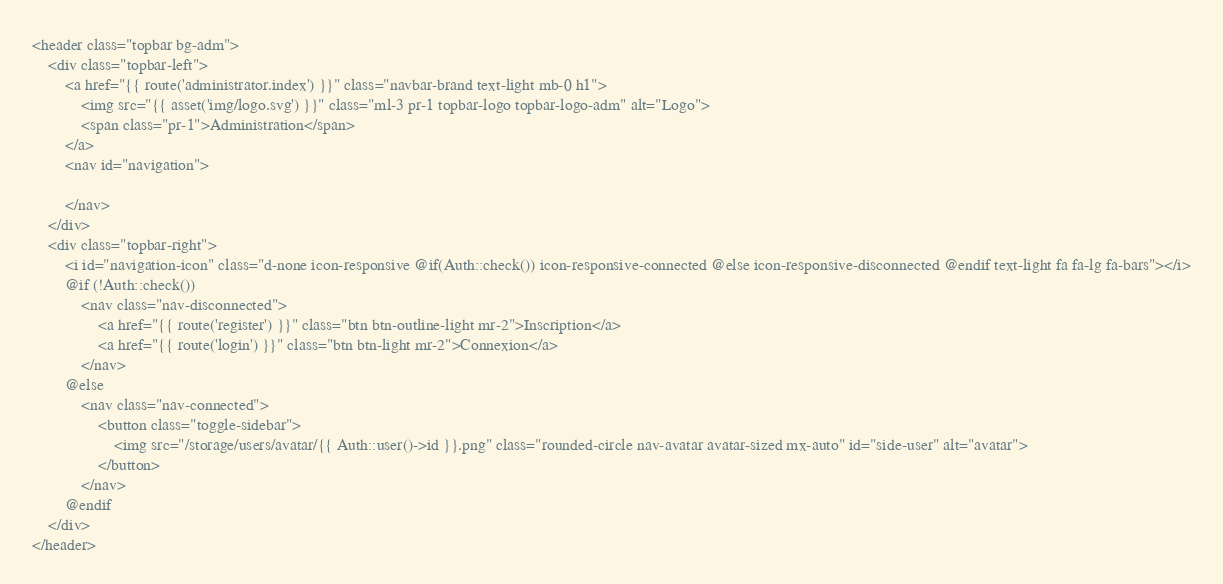<code> <loc_0><loc_0><loc_500><loc_500><_PHP_><header class="topbar bg-adm"> 
    <div class="topbar-left">      
        <a href="{{ route('administrator.index') }}" class="navbar-brand text-light mb-0 h1">
            <img src="{{ asset('img/logo.svg') }}" class="ml-3 pr-1 topbar-logo topbar-logo-adm" alt="Logo">
            <span class="pr-1">Administration</span>
        </a>
        <nav id="navigation">

        </nav>
    </div>
    <div class="topbar-right">
        <i id="navigation-icon" class="d-none icon-responsive @if(Auth::check()) icon-responsive-connected @else icon-responsive-disconnected @endif text-light fa fa-lg fa-bars"></i>
        @if (!Auth::check())
            <nav class="nav-disconnected">
                <a href="{{ route('register') }}" class="btn btn-outline-light mr-2">Inscription</a>
                <a href="{{ route('login') }}" class="btn btn-light mr-2">Connexion</a>
            </nav>
        @else
            <nav class="nav-connected">
                <button class="toggle-sidebar">
                    <img src="/storage/users/avatar/{{ Auth::user()->id }}.png" class="rounded-circle nav-avatar avatar-sized mx-auto" id="side-user" alt="avatar">   
                </button>
            </nav>
        @endif  
    </div>   
</header>
</code> 